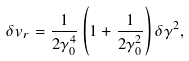Convert formula to latex. <formula><loc_0><loc_0><loc_500><loc_500>\delta v _ { r } = \frac { 1 } { 2 \gamma _ { 0 } ^ { 4 } } \left ( 1 + \frac { 1 } { 2 \gamma _ { 0 } ^ { 2 } } \right ) \delta \gamma ^ { 2 } ,</formula> 